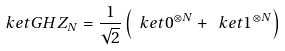<formula> <loc_0><loc_0><loc_500><loc_500>\ k e t { G H Z _ { N } } = \frac { 1 } { \sqrt { 2 } } \left ( \ k e t { 0 } ^ { \otimes N } + \ k e t { 1 } ^ { \otimes N } \right )</formula> 